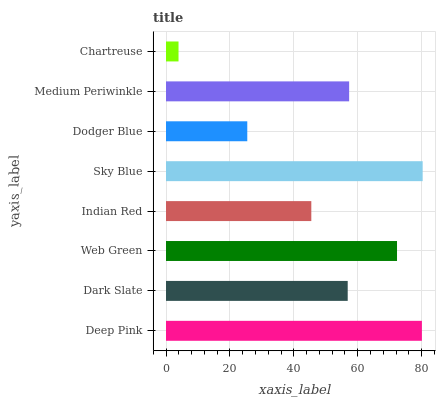Is Chartreuse the minimum?
Answer yes or no. Yes. Is Sky Blue the maximum?
Answer yes or no. Yes. Is Dark Slate the minimum?
Answer yes or no. No. Is Dark Slate the maximum?
Answer yes or no. No. Is Deep Pink greater than Dark Slate?
Answer yes or no. Yes. Is Dark Slate less than Deep Pink?
Answer yes or no. Yes. Is Dark Slate greater than Deep Pink?
Answer yes or no. No. Is Deep Pink less than Dark Slate?
Answer yes or no. No. Is Medium Periwinkle the high median?
Answer yes or no. Yes. Is Dark Slate the low median?
Answer yes or no. Yes. Is Indian Red the high median?
Answer yes or no. No. Is Chartreuse the low median?
Answer yes or no. No. 